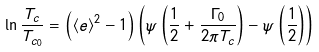Convert formula to latex. <formula><loc_0><loc_0><loc_500><loc_500>\ln \frac { T _ { c } } { T _ { c _ { 0 } } } = \left ( \left < e \right > ^ { 2 } - 1 \right ) \left ( \psi \left ( \frac { 1 } { 2 } + \frac { \Gamma _ { 0 } } { 2 \pi T _ { c } } \right ) - \psi \left ( \frac { 1 } { 2 } \right ) \right )</formula> 